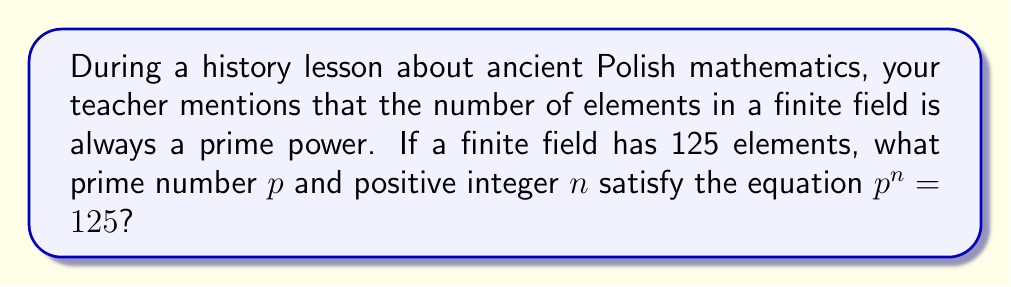Can you answer this question? Let's approach this step-by-step:

1) We know that the number of elements in a finite field is 125.

2) We need to find a prime number $p$ and a positive integer $n$ such that $p^n = 125$.

3) To find the prime factors of 125, let's break it down:
   $$125 = 5 \times 5 \times 5 = 5^3$$

4) From this factorization, we can see that:
   - The prime number $p$ is 5
   - The exponent $n$ is 3

5) We can verify:
   $$5^3 = 5 \times 5 \times 5 = 125$$

Therefore, the prime number $p$ is 5, and the positive integer $n$ is 3.
Answer: $p = 5$, $n = 3$ 